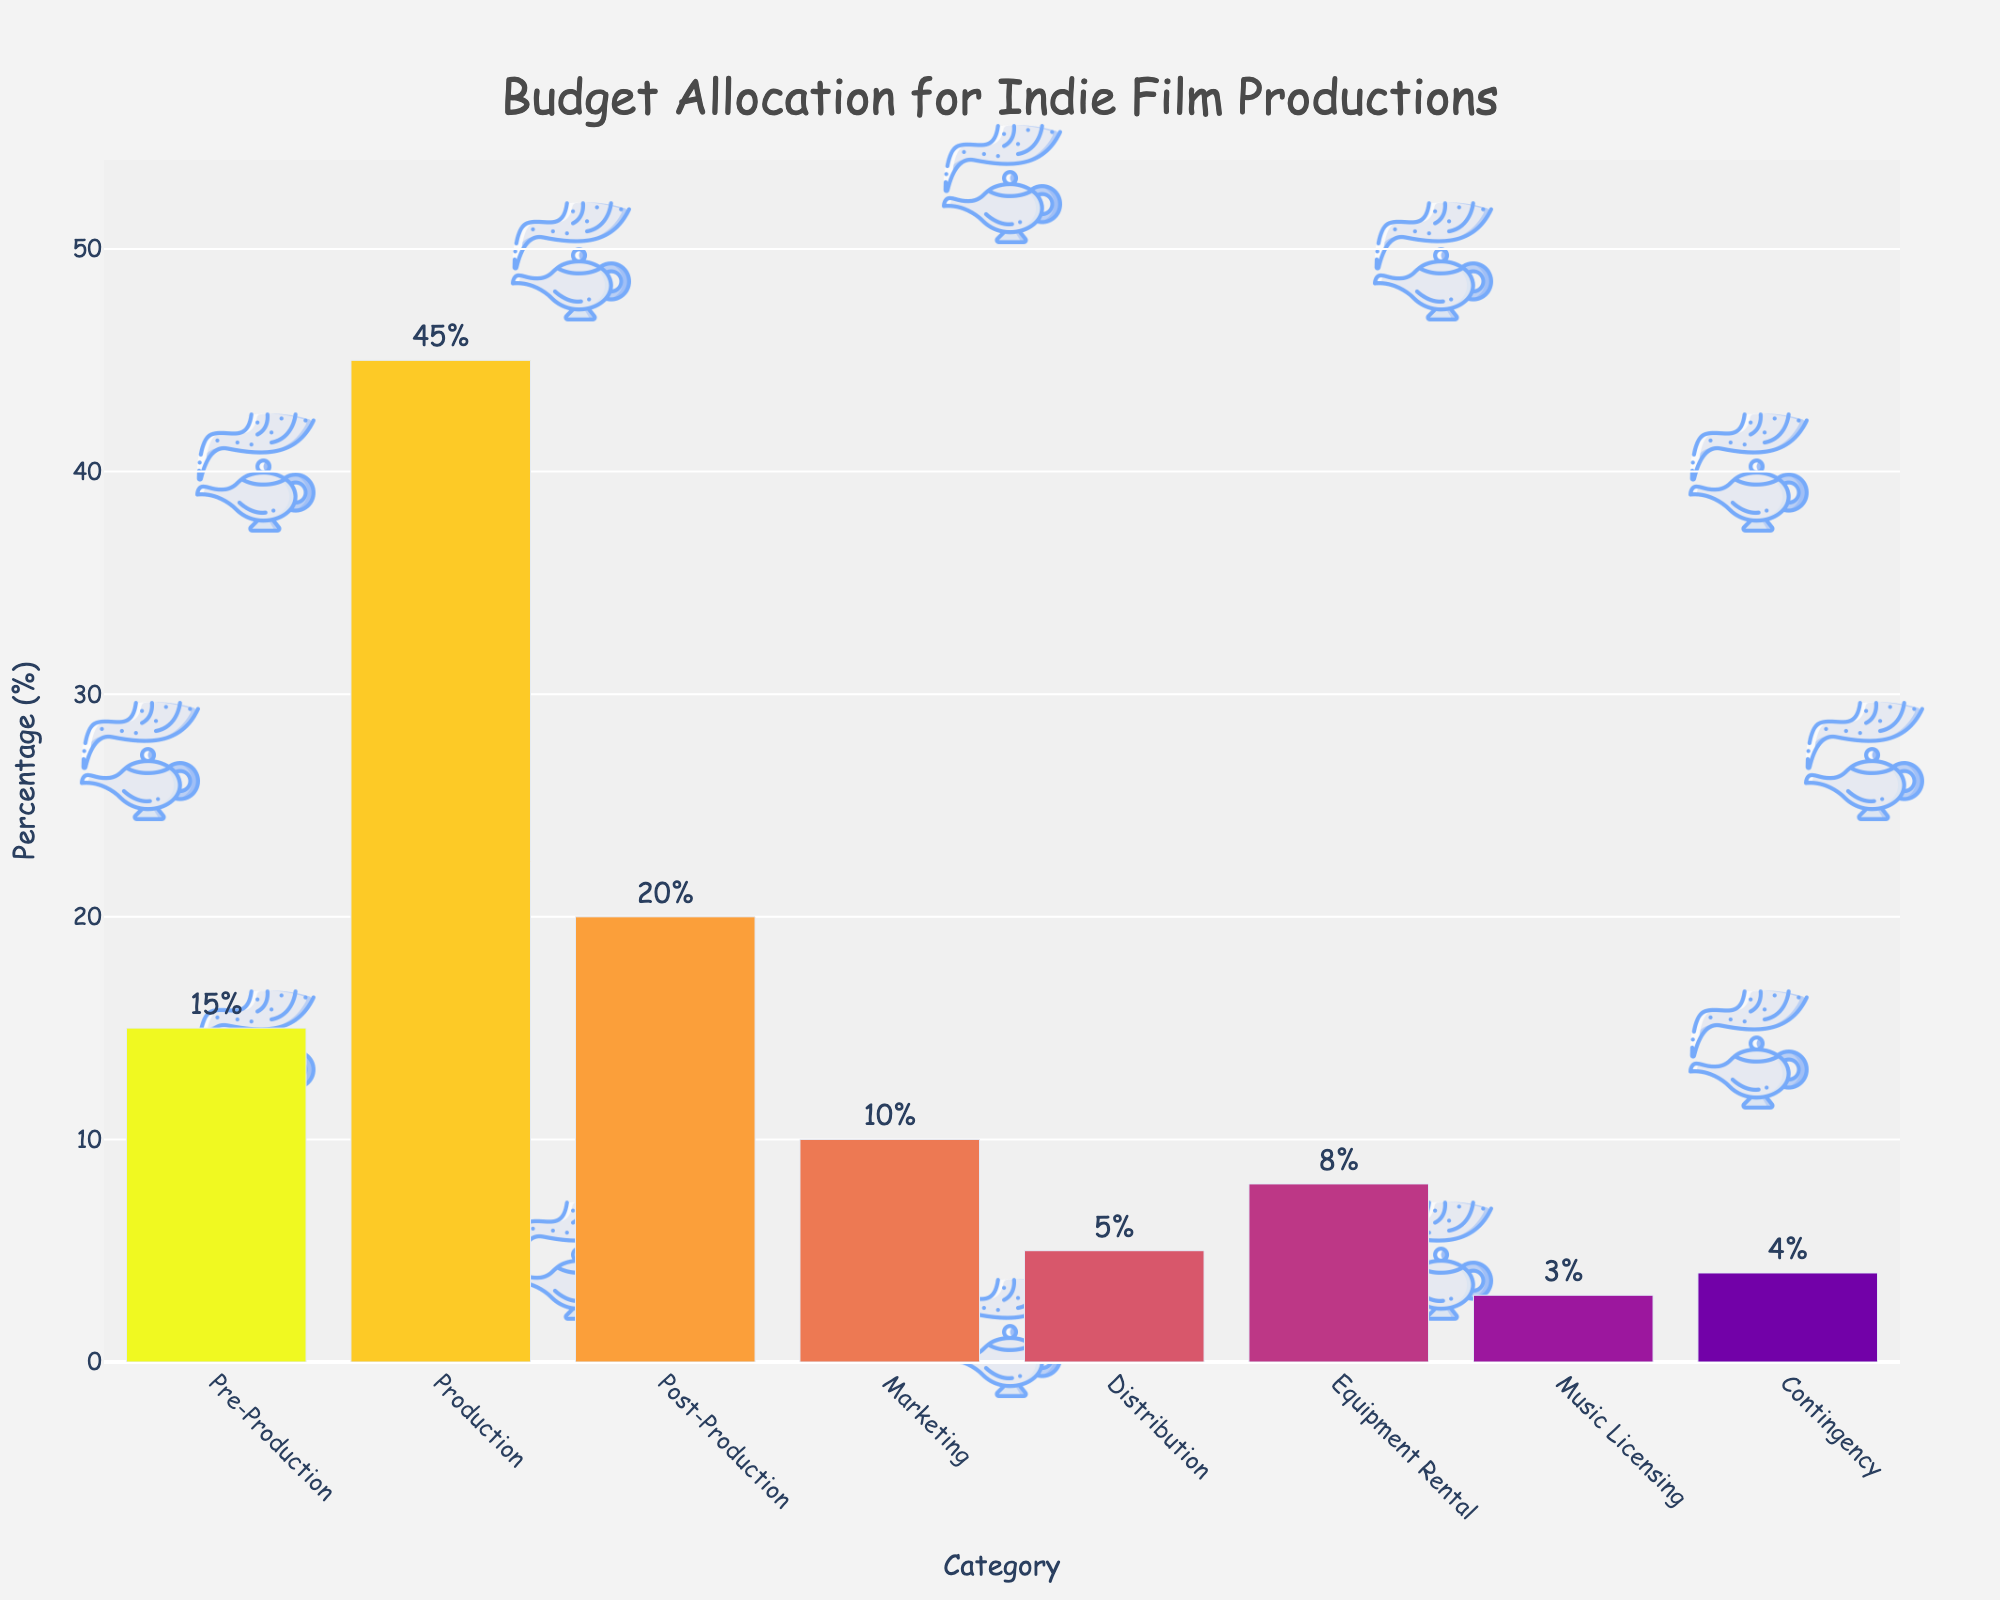Which budget category has the highest allocation? The highest allocation can be determined by looking at the tallest bar in the chart. The "Production" category has the tallest bar indicating it has the highest budget allocation.
Answer: Production What is the combined budget percentage for Pre-Production and Post-Production? To find the combined budget percentage, add the percentages allocated to "Pre-Production" and "Post-Production": 15% + 20%.
Answer: 35% Which has a larger budget allocation, Equipment Rental or Marketing? To compare, examine the bars for "Equipment Rental" and "Marketing". The height of the bar for "Equipment Rental" (8%) is greater than that for "Marketing" (10%).
Answer: Marketing What is the difference in budget allocation between Production and Contingency? Calculate the difference by subtracting the percentage for "Contingency" from "Production": 45% - 4%.
Answer: 41% What is the average budget allocation across all categories? Add all the percentages together and divide by the number of categories: (15% + 45% + 20% + 10% + 5% + 8% + 3% + 4%) and divide by 8. This sums up to 110% and (110/8) = 13.75%.
Answer: 13.75% Which categories have a budget allocation less than 10%? Identify bars shorter than the 10% mark on the y-axis. These categories are "Distribution" (5%), "Equipment Rental" (8%), "Music Licensing" (3%), and "Contingency" (4%).
Answer: Distribution, Equipment Rental, Music Licensing, Contingency By how much is the budget allocation for Post-Production greater than for Distribution? Subtract the percentage for "Distribution" from "Post-Production": 20% - 5%.
Answer: 15% Which visual elements indicate the allocation for Contingency? Contingency is represented by a bar. Its height matches the 4% mark on the y-axis, and it is labeled as "Contingency" with "4%" displayed above.
Answer: Bar labeled Contingency with 4% 